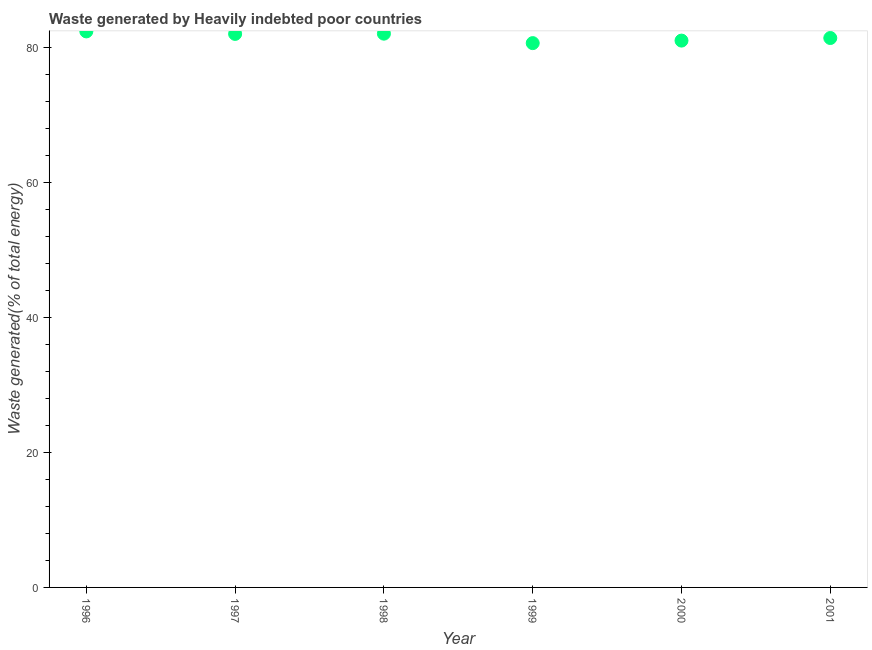What is the amount of waste generated in 2001?
Your answer should be compact. 81.4. Across all years, what is the maximum amount of waste generated?
Offer a terse response. 82.38. Across all years, what is the minimum amount of waste generated?
Keep it short and to the point. 80.64. In which year was the amount of waste generated maximum?
Give a very brief answer. 1996. In which year was the amount of waste generated minimum?
Make the answer very short. 1999. What is the sum of the amount of waste generated?
Give a very brief answer. 489.48. What is the difference between the amount of waste generated in 1999 and 2001?
Provide a short and direct response. -0.76. What is the average amount of waste generated per year?
Offer a very short reply. 81.58. What is the median amount of waste generated?
Your response must be concise. 81.7. In how many years, is the amount of waste generated greater than 72 %?
Your answer should be very brief. 6. Do a majority of the years between 1996 and 1999 (inclusive) have amount of waste generated greater than 72 %?
Provide a succinct answer. Yes. What is the ratio of the amount of waste generated in 1997 to that in 2001?
Make the answer very short. 1.01. Is the amount of waste generated in 1997 less than that in 1999?
Give a very brief answer. No. What is the difference between the highest and the second highest amount of waste generated?
Make the answer very short. 0.33. Is the sum of the amount of waste generated in 1996 and 2000 greater than the maximum amount of waste generated across all years?
Provide a short and direct response. Yes. What is the difference between the highest and the lowest amount of waste generated?
Offer a terse response. 1.73. Does the amount of waste generated monotonically increase over the years?
Offer a very short reply. No. How many dotlines are there?
Ensure brevity in your answer.  1. What is the difference between two consecutive major ticks on the Y-axis?
Offer a terse response. 20. Does the graph contain any zero values?
Make the answer very short. No. What is the title of the graph?
Your answer should be compact. Waste generated by Heavily indebted poor countries. What is the label or title of the Y-axis?
Provide a short and direct response. Waste generated(% of total energy). What is the Waste generated(% of total energy) in 1996?
Your answer should be compact. 82.38. What is the Waste generated(% of total energy) in 1997?
Offer a terse response. 82. What is the Waste generated(% of total energy) in 1998?
Offer a very short reply. 82.04. What is the Waste generated(% of total energy) in 1999?
Your answer should be very brief. 80.64. What is the Waste generated(% of total energy) in 2000?
Offer a terse response. 81.02. What is the Waste generated(% of total energy) in 2001?
Offer a terse response. 81.4. What is the difference between the Waste generated(% of total energy) in 1996 and 1997?
Your response must be concise. 0.37. What is the difference between the Waste generated(% of total energy) in 1996 and 1998?
Give a very brief answer. 0.33. What is the difference between the Waste generated(% of total energy) in 1996 and 1999?
Offer a terse response. 1.73. What is the difference between the Waste generated(% of total energy) in 1996 and 2000?
Keep it short and to the point. 1.36. What is the difference between the Waste generated(% of total energy) in 1996 and 2001?
Your response must be concise. 0.98. What is the difference between the Waste generated(% of total energy) in 1997 and 1998?
Provide a short and direct response. -0.04. What is the difference between the Waste generated(% of total energy) in 1997 and 1999?
Offer a terse response. 1.36. What is the difference between the Waste generated(% of total energy) in 1997 and 2000?
Provide a short and direct response. 0.99. What is the difference between the Waste generated(% of total energy) in 1997 and 2001?
Your answer should be compact. 0.61. What is the difference between the Waste generated(% of total energy) in 1998 and 1999?
Make the answer very short. 1.4. What is the difference between the Waste generated(% of total energy) in 1998 and 2000?
Provide a succinct answer. 1.03. What is the difference between the Waste generated(% of total energy) in 1998 and 2001?
Your answer should be very brief. 0.64. What is the difference between the Waste generated(% of total energy) in 1999 and 2000?
Your answer should be very brief. -0.37. What is the difference between the Waste generated(% of total energy) in 1999 and 2001?
Provide a short and direct response. -0.76. What is the difference between the Waste generated(% of total energy) in 2000 and 2001?
Your answer should be very brief. -0.38. What is the ratio of the Waste generated(% of total energy) in 1996 to that in 1997?
Provide a succinct answer. 1. What is the ratio of the Waste generated(% of total energy) in 1996 to that in 1998?
Give a very brief answer. 1. What is the ratio of the Waste generated(% of total energy) in 1996 to that in 2000?
Make the answer very short. 1.02. What is the ratio of the Waste generated(% of total energy) in 1997 to that in 1998?
Your answer should be compact. 1. What is the ratio of the Waste generated(% of total energy) in 1997 to that in 2000?
Ensure brevity in your answer.  1.01. What is the ratio of the Waste generated(% of total energy) in 1998 to that in 2000?
Offer a terse response. 1.01. What is the ratio of the Waste generated(% of total energy) in 1999 to that in 2001?
Make the answer very short. 0.99. 